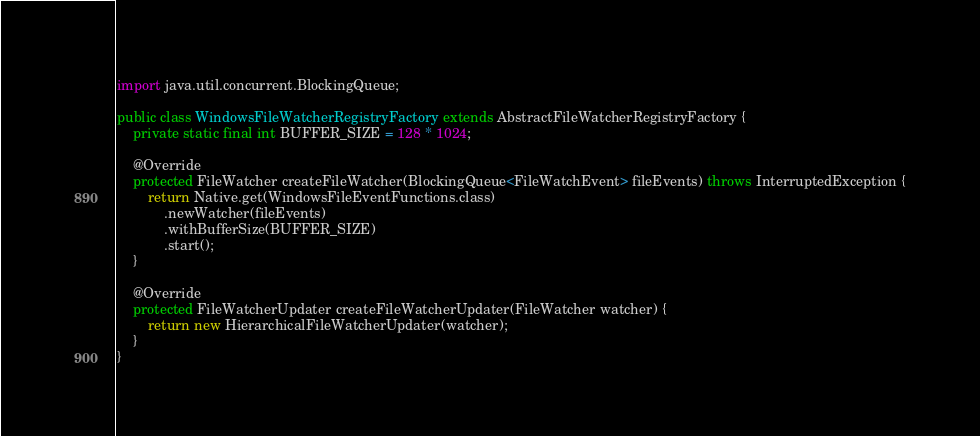Convert code to text. <code><loc_0><loc_0><loc_500><loc_500><_Java_>
import java.util.concurrent.BlockingQueue;

public class WindowsFileWatcherRegistryFactory extends AbstractFileWatcherRegistryFactory {
    private static final int BUFFER_SIZE = 128 * 1024;

    @Override
    protected FileWatcher createFileWatcher(BlockingQueue<FileWatchEvent> fileEvents) throws InterruptedException {
        return Native.get(WindowsFileEventFunctions.class)
            .newWatcher(fileEvents)
            .withBufferSize(BUFFER_SIZE)
            .start();
    }

    @Override
    protected FileWatcherUpdater createFileWatcherUpdater(FileWatcher watcher) {
        return new HierarchicalFileWatcherUpdater(watcher);
    }
}
</code> 